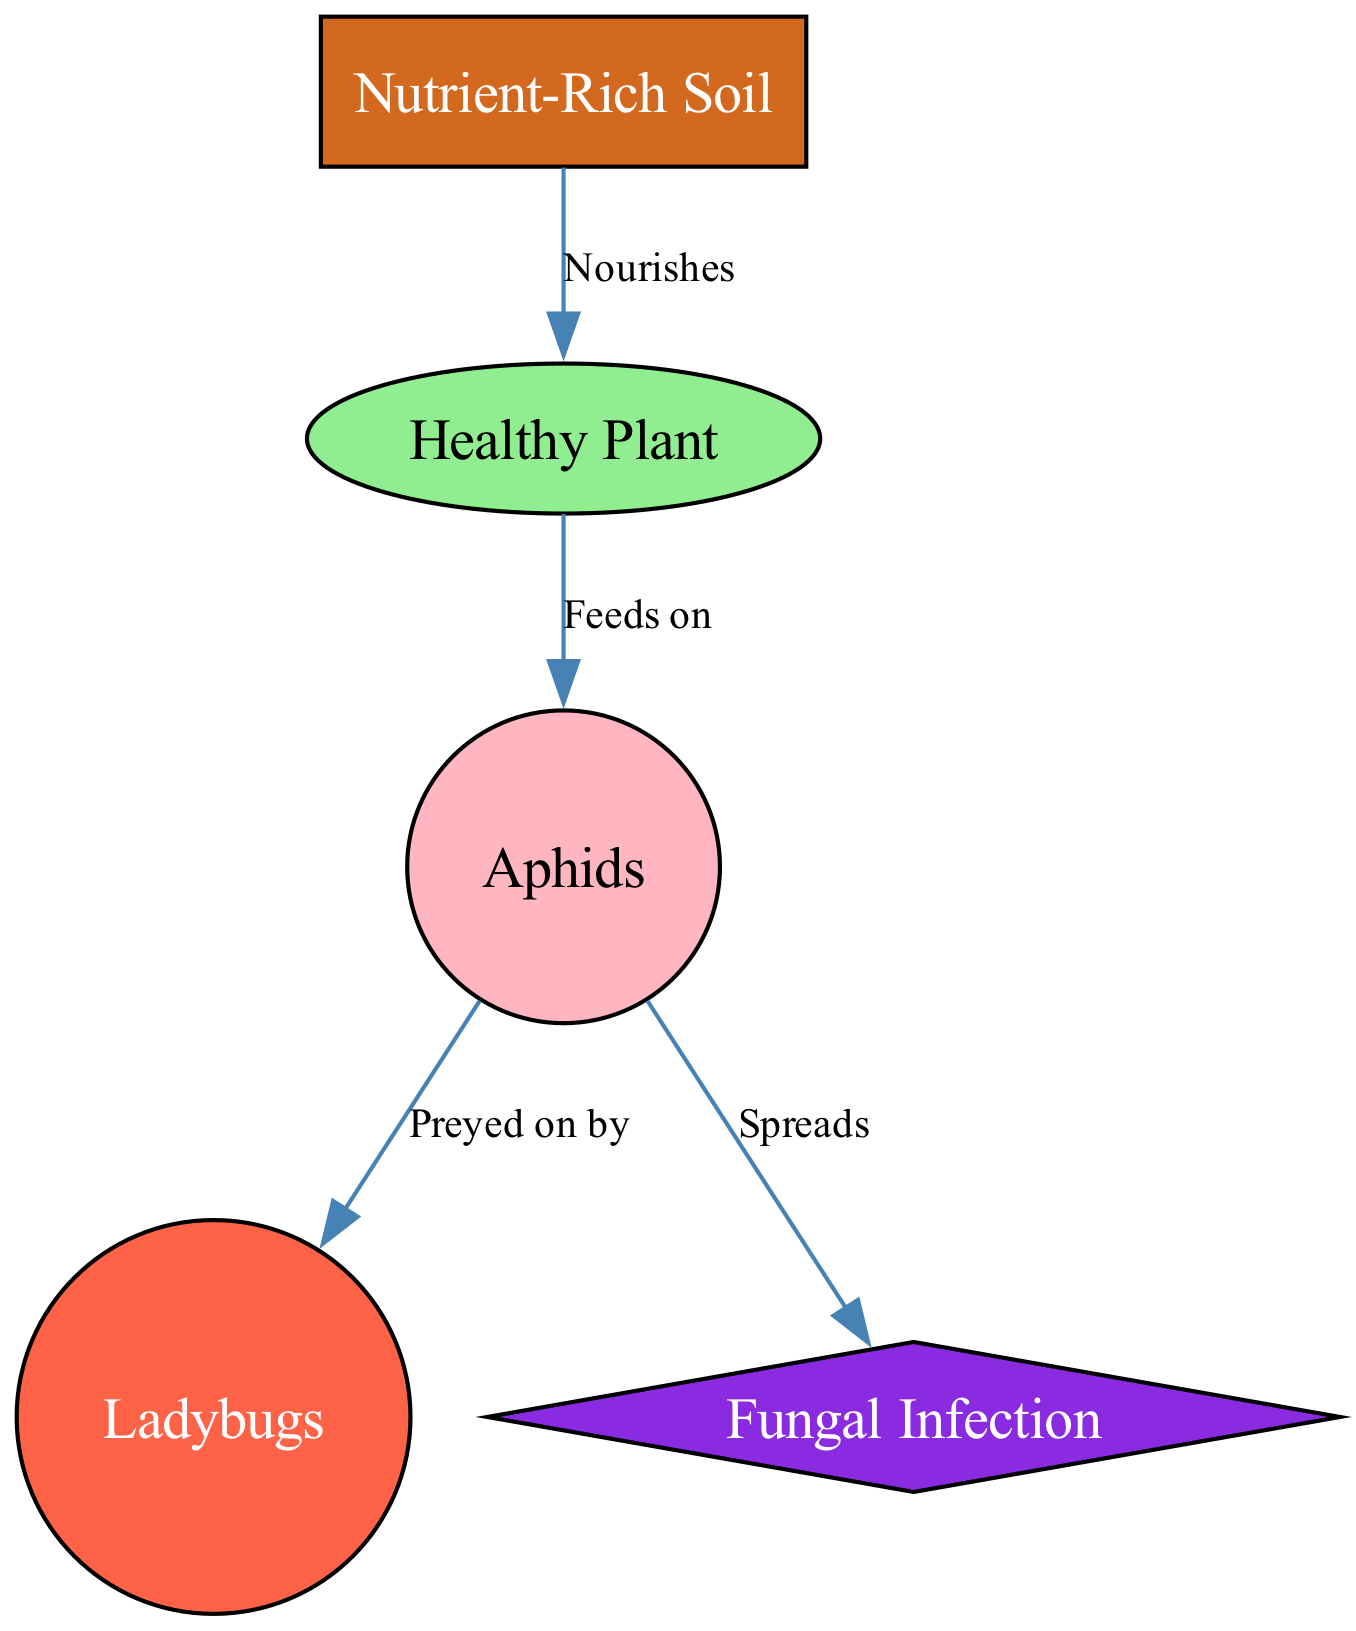What is the total number of nodes in the diagram? The diagram lists five distinct entities: Healthy Plant, Aphids, Ladybugs, Fungal Infection, and Nutrient-Rich Soil. Counting these gives us a total of five nodes.
Answer: 5 What do aphids feed on? The diagram shows a directed edge from Healthy Plant to Aphids labeled "Feeds on," indicating that aphids consume healthy plants.
Answer: Healthy Plant How many edges are pointing to the ladybug? The ladybug only has one directed edge pointing to it from the aphid, labeled "Preyed on by." Therefore, there is one edge pointing to the ladybug.
Answer: 1 What is the relationship between aphids and fungal infection? According to the diagram, there is a directed edge from aphids to fungal infection with the label "Spreads," illustrating that aphids contribute to the spread of fungal infections.
Answer: Spreads If a plant is in nutrient-rich soil, what is its health status likely to be? The diagram indicates that nutrient-rich soil nourishes plants, implying that if a plant is receiving such support, it should be healthy. Therefore, the health status of the plant is likely healthy.
Answer: Healthy Which insect preys on aphids? The directed edge in the diagram specifies that Ladybugs prey on aphids, establishing a predator-prey relationship between the two.
Answer: Ladybugs What is the main effect of aphids on healthy plants? The diagram indicates a direct feeding relationship, showing that aphids feed on healthy plants, which generally leads to detrimental effects on the plants' health.
Answer: Feeds on How does nutrient-rich soil affect plant health? The relationship illustrated in the diagram shows that nutrient-rich soil nourishes plants. This means that healthy soil positively impacts the overall health of the plants.
Answer: Nourishes What does healthy plant status depend on in this food chain? The health status of the plant relies on multiple factors, particularly the availability of nutrient-rich soil for nourishment and the absence of harmful organisms like aphids and fungi. Therefore, it depends on the nutrients and the absence of pests.
Answer: Nutrient-Rich Soil 